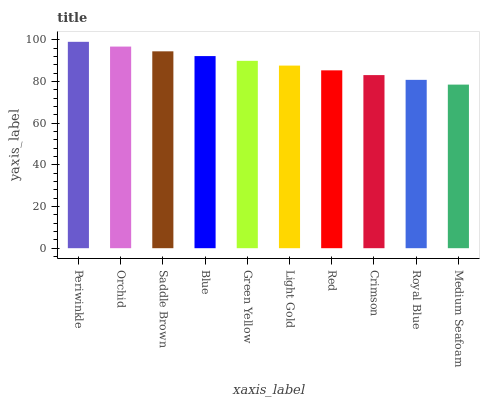Is Medium Seafoam the minimum?
Answer yes or no. Yes. Is Periwinkle the maximum?
Answer yes or no. Yes. Is Orchid the minimum?
Answer yes or no. No. Is Orchid the maximum?
Answer yes or no. No. Is Periwinkle greater than Orchid?
Answer yes or no. Yes. Is Orchid less than Periwinkle?
Answer yes or no. Yes. Is Orchid greater than Periwinkle?
Answer yes or no. No. Is Periwinkle less than Orchid?
Answer yes or no. No. Is Green Yellow the high median?
Answer yes or no. Yes. Is Light Gold the low median?
Answer yes or no. Yes. Is Periwinkle the high median?
Answer yes or no. No. Is Red the low median?
Answer yes or no. No. 